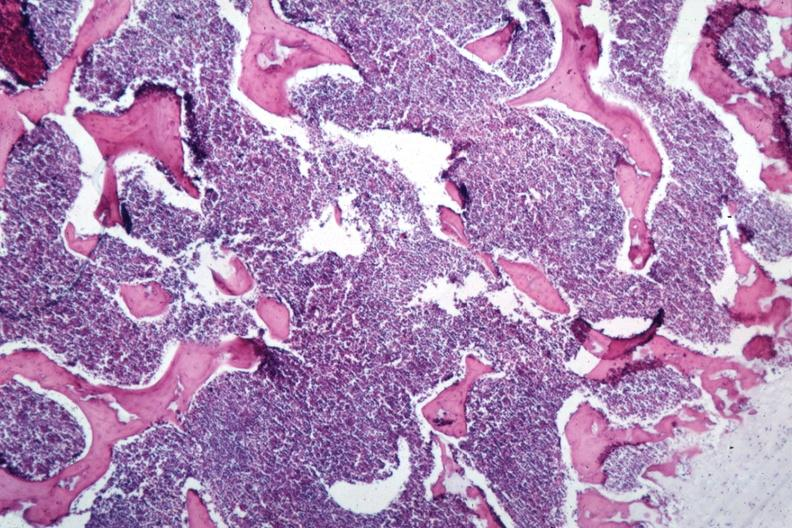what does this image show?
Answer the question using a single word or phrase. Sheets of lymphoma cells 